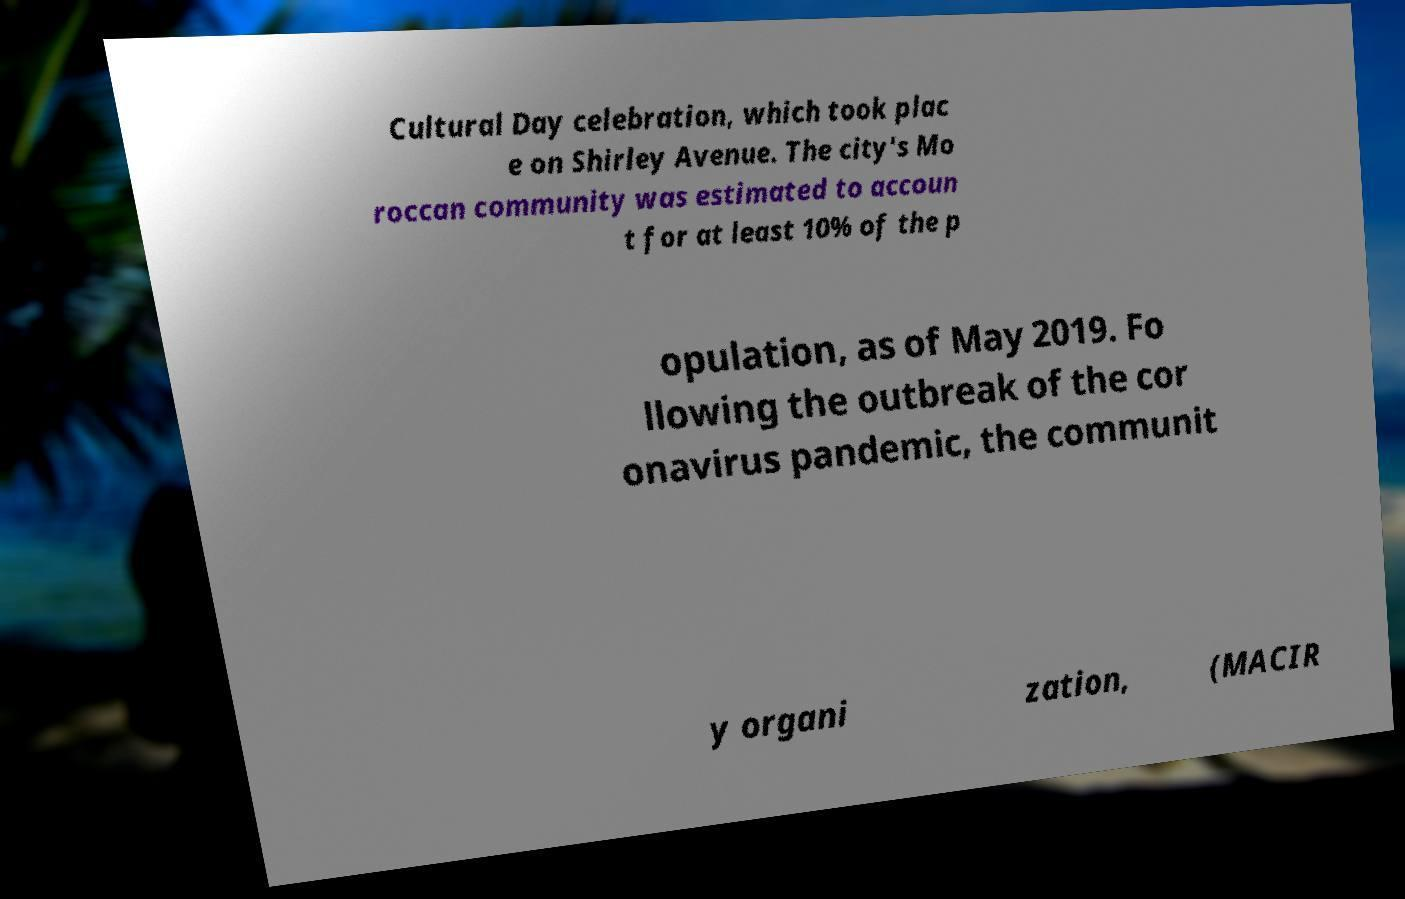Please identify and transcribe the text found in this image. Cultural Day celebration, which took plac e on Shirley Avenue. The city's Mo roccan community was estimated to accoun t for at least 10% of the p opulation, as of May 2019. Fo llowing the outbreak of the cor onavirus pandemic, the communit y organi zation, (MACIR 